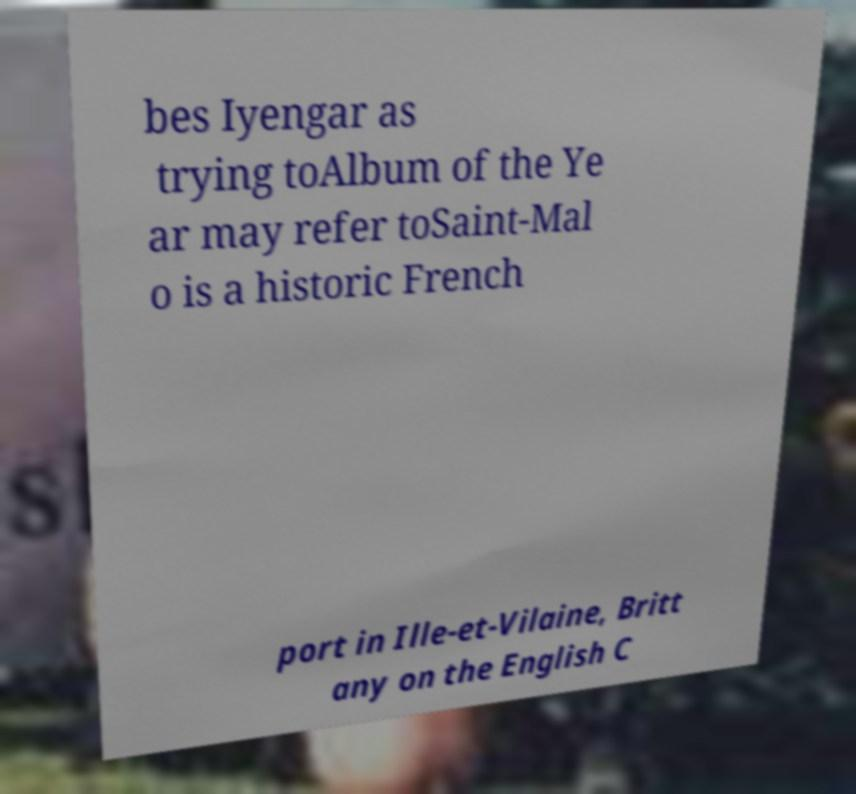There's text embedded in this image that I need extracted. Can you transcribe it verbatim? bes Iyengar as trying toAlbum of the Ye ar may refer toSaint-Mal o is a historic French port in Ille-et-Vilaine, Britt any on the English C 